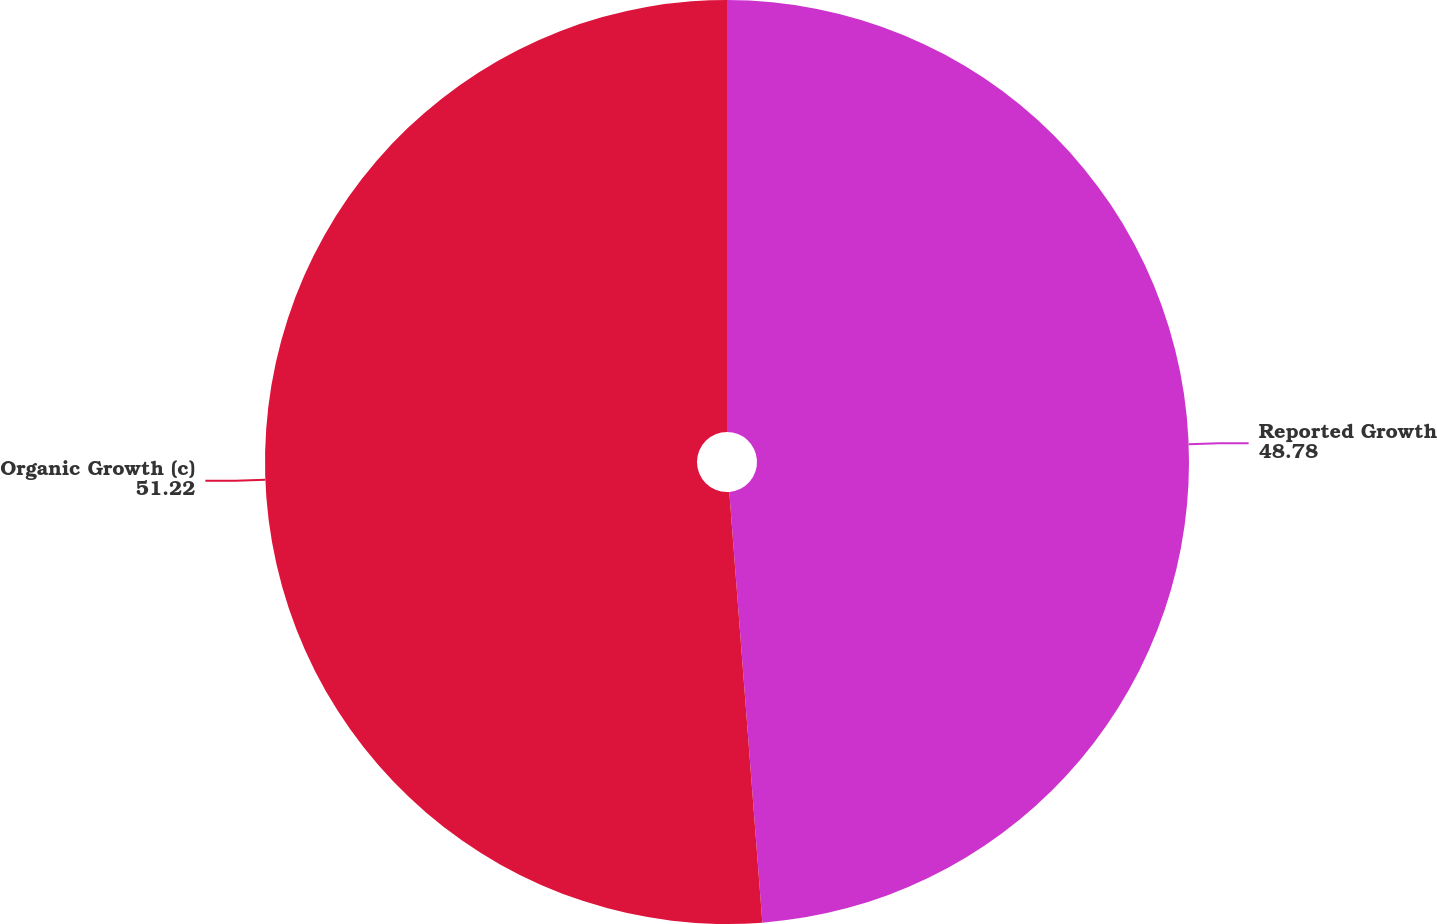Convert chart to OTSL. <chart><loc_0><loc_0><loc_500><loc_500><pie_chart><fcel>Reported Growth<fcel>Organic Growth (c)<nl><fcel>48.78%<fcel>51.22%<nl></chart> 